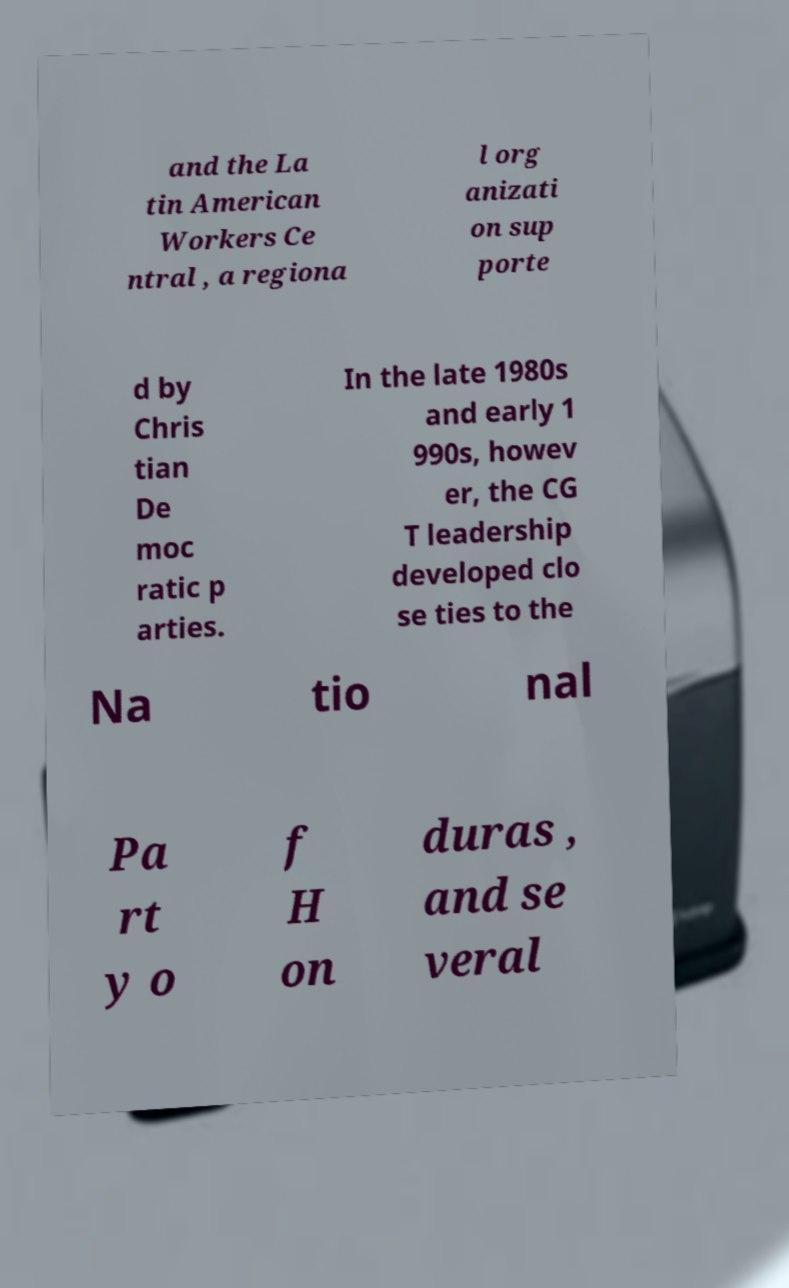Could you assist in decoding the text presented in this image and type it out clearly? and the La tin American Workers Ce ntral , a regiona l org anizati on sup porte d by Chris tian De moc ratic p arties. In the late 1980s and early 1 990s, howev er, the CG T leadership developed clo se ties to the Na tio nal Pa rt y o f H on duras , and se veral 